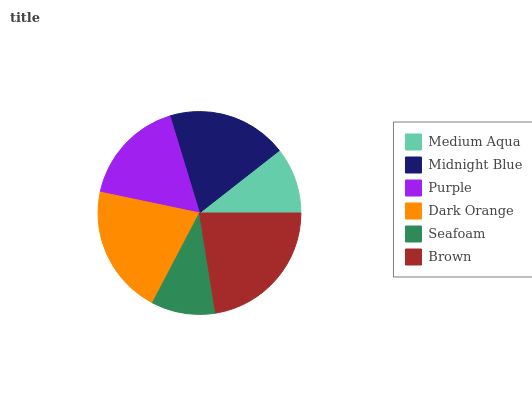Is Seafoam the minimum?
Answer yes or no. Yes. Is Brown the maximum?
Answer yes or no. Yes. Is Midnight Blue the minimum?
Answer yes or no. No. Is Midnight Blue the maximum?
Answer yes or no. No. Is Midnight Blue greater than Medium Aqua?
Answer yes or no. Yes. Is Medium Aqua less than Midnight Blue?
Answer yes or no. Yes. Is Medium Aqua greater than Midnight Blue?
Answer yes or no. No. Is Midnight Blue less than Medium Aqua?
Answer yes or no. No. Is Midnight Blue the high median?
Answer yes or no. Yes. Is Purple the low median?
Answer yes or no. Yes. Is Seafoam the high median?
Answer yes or no. No. Is Brown the low median?
Answer yes or no. No. 